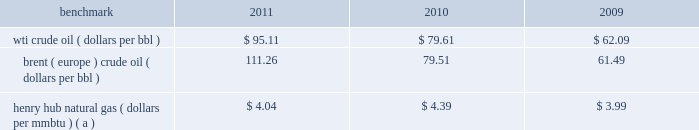Item 7 .
Management 2019s discussion and analysis of financial condition and results of operations we are an international energy company with operations in the u.s. , canada , africa , the middle east and europe .
Our operations are organized into three reportable segments : 2022 e&p which explores for , produces and markets liquid hydrocarbons and natural gas on a worldwide basis .
2022 osm which mines , extracts and transports bitumen from oil sands deposits in alberta , canada , and upgrades the bitumen to produce and market synthetic crude oil and vacuum gas oil .
2022 ig which produces and markets products manufactured from natural gas , such as lng and methanol , in eg .
Certain sections of management 2019s discussion and analysis of financial condition and results of operations include forward-looking statements concerning trends or events potentially affecting our business .
These statements typically contain words such as 201canticipates , 201d 201cbelieves , 201d 201cestimates , 201d 201cexpects , 201d 201ctargets , 201d 201cplans , 201d 201cprojects , 201d 201ccould , 201d 201cmay , 201d 201cshould , 201d 201cwould 201d or similar words indicating that future outcomes are uncertain .
In accordance with 201csafe harbor 201d provisions of the private securities litigation reform act of 1995 , these statements are accompanied by cautionary language identifying important factors , though not necessarily all such factors , which could cause future outcomes to differ materially from those set forth in forward-looking statements .
For additional risk factors affecting our business , see item 1a .
Risk factors in this annual report on form 10-k .
Management 2019s discussion and analysis of financial condition and results of operations should be read in conjunction with the information under item 1 .
Business , item 1a .
Risk factors and item 8 .
Financial statements and supplementary data found in this annual report on form 10-k .
Spin-off downstream business on june 30 , 2011 , the spin-off of marathon 2019s downstream business was completed , creating two independent energy companies : marathon oil and mpc .
Marathon shareholders at the close of business on the record date of june 27 , 2011 received one share of mpc common stock for every two shares of marathon common stock held .
Fractional shares of mpc common stock were not distributed and any fractional share of mpc common stock otherwise issuable to a marathon shareholder was sold in the open market on such shareholder 2019s behalf , and such shareholder received a cash payment with respect to that fractional share .
A private letter tax ruling received in june 2011 from the irs affirmed the tax-free nature of the spin-off .
Activities related to the downstream business have been treated as discontinued operations in all periods presented in this annual report on form 10-k ( see item 8 .
Financial statements and supplementary data 2014note 3 to the consolidated financial statements for additional information ) .
Overview 2013 market conditions exploration and production prevailing prices for the various grades of crude oil and natural gas that we produce significantly impact our revenues and cash flows .
Prices of crude oil have been volatile in recent years .
In 2011 , crude prices increased over 2010 levels , with increases in brent averages outstripping those in wti .
During much of 2010 , both wti and brent crude oil monthly average prices remained in the $ 75 to $ 85 per barrel range .
Crude oil prices reached a low of $ 33.98 in february 2009 , following global demand declines in an economic recession , but recovered quickly ending 2009 at $ 79.36 .
The table lists benchmark crude oil and natural gas price annual averages for the past three years. .
Wti crude oil ( dollars per bbl ) $ 95.11 $ 79.61 $ 62.09 brent ( europe ) crude oil ( dollars per bbl ) 111.26 79.51 61.49 henry hub natural gas ( dollars per mmbtu ) ( a ) $ 4.04 $ 4.39 $ 3.99 ( a ) settlement date average .
Our u.s .
Crude oil production was approximately 58 percent sour in 2011 and 68 percent in 2010 .
Sour crude contains more sulfur than light sweet wti does .
Sour crude oil also tends to be heavier than light sweet crude oil and sells at a discount to light sweet crude oil because of higher refining costs and lower refined product values .
Our international crude oil production is relatively sweet and is generally sold in relation to the brent crude benchmark .
The differential between wti and brent average prices widened significantly in 2011 to $ 16.15 in comparison to differentials of less than $ 1.00 in 2010 and 2009. .
By how much did the wti crude oil benchmark increase from 2009 to 2011? 
Computations: ((95.11 - 62.09) / 62.09)
Answer: 0.53181. 